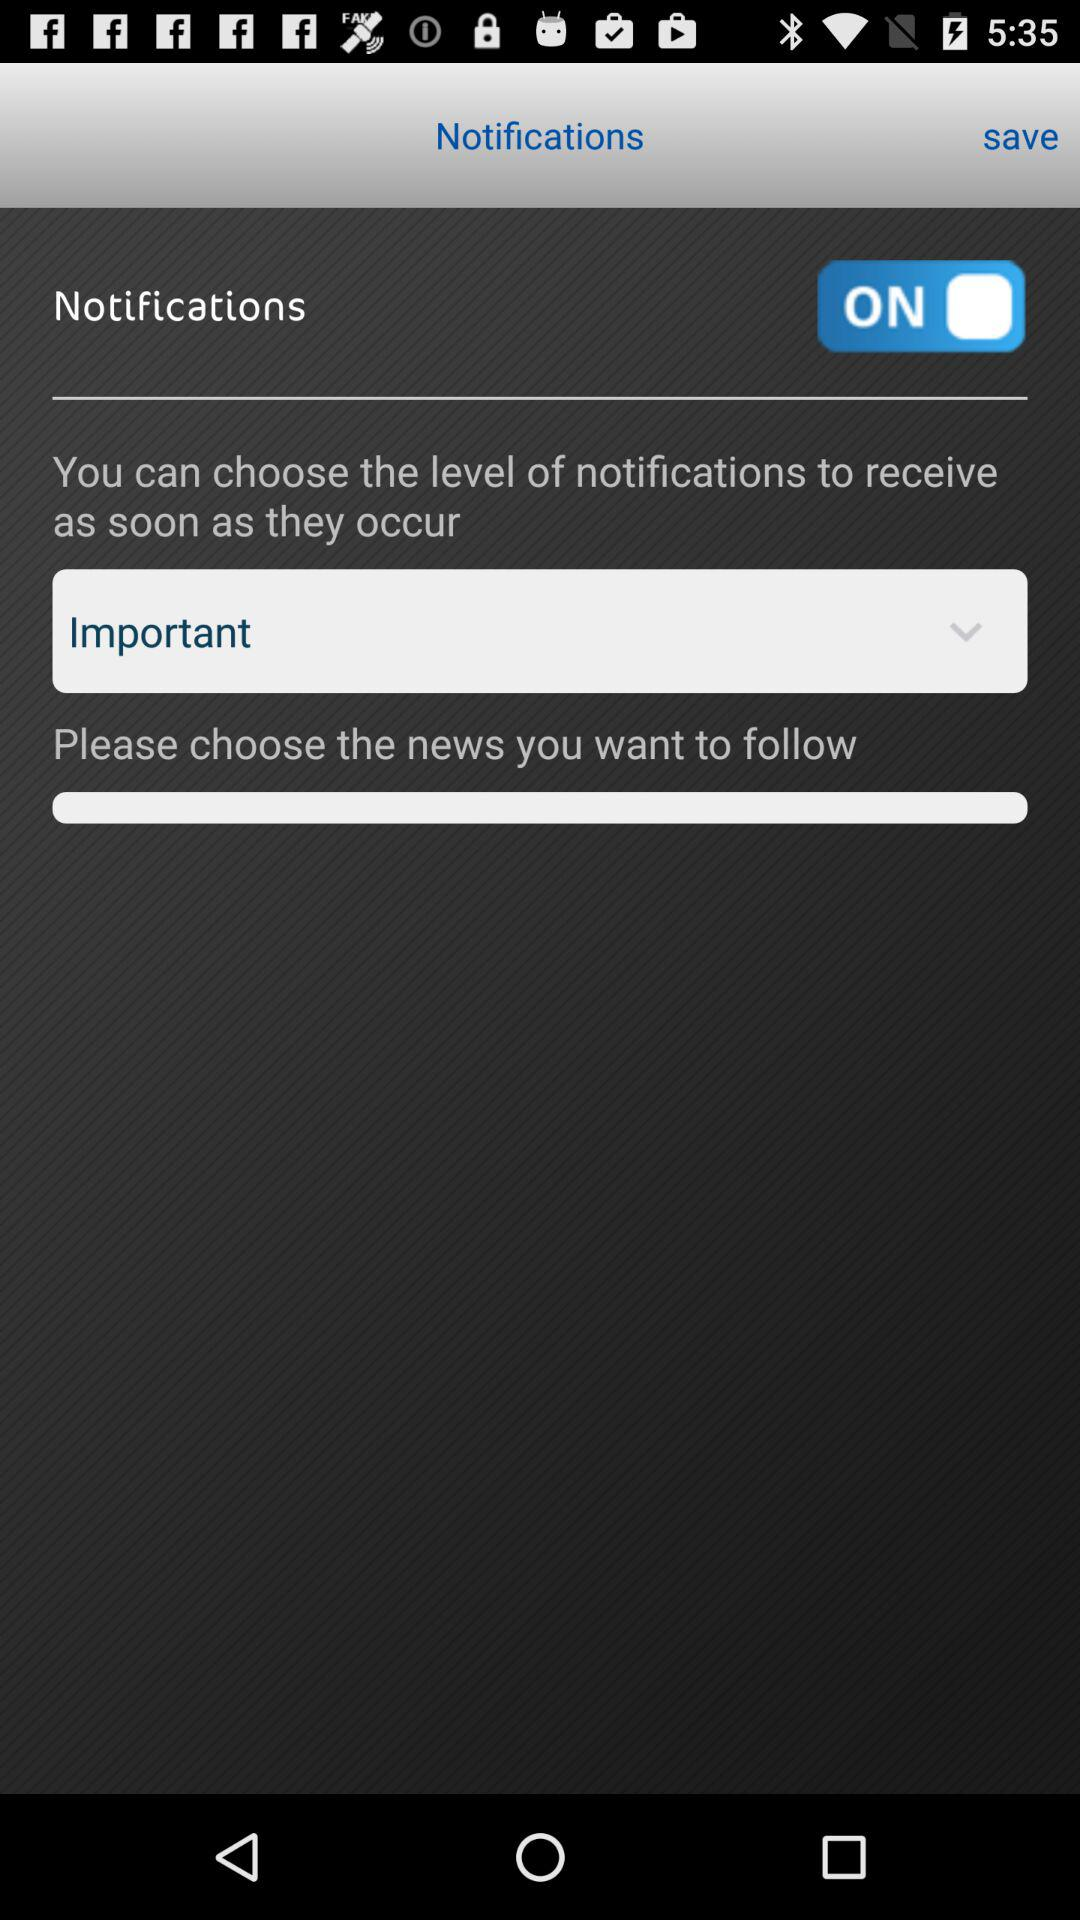What is the selected level of notifications? The selected level of notifications is "Important". 